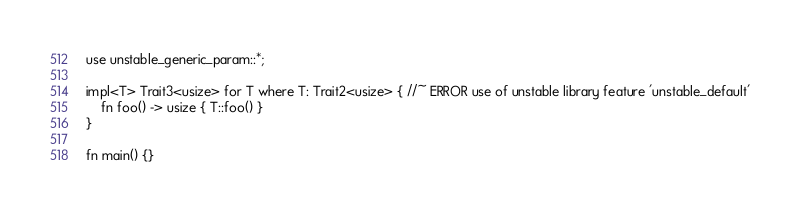Convert code to text. <code><loc_0><loc_0><loc_500><loc_500><_Rust_>use unstable_generic_param::*;

impl<T> Trait3<usize> for T where T: Trait2<usize> { //~ ERROR use of unstable library feature 'unstable_default'
    fn foo() -> usize { T::foo() }
}

fn main() {}
</code> 